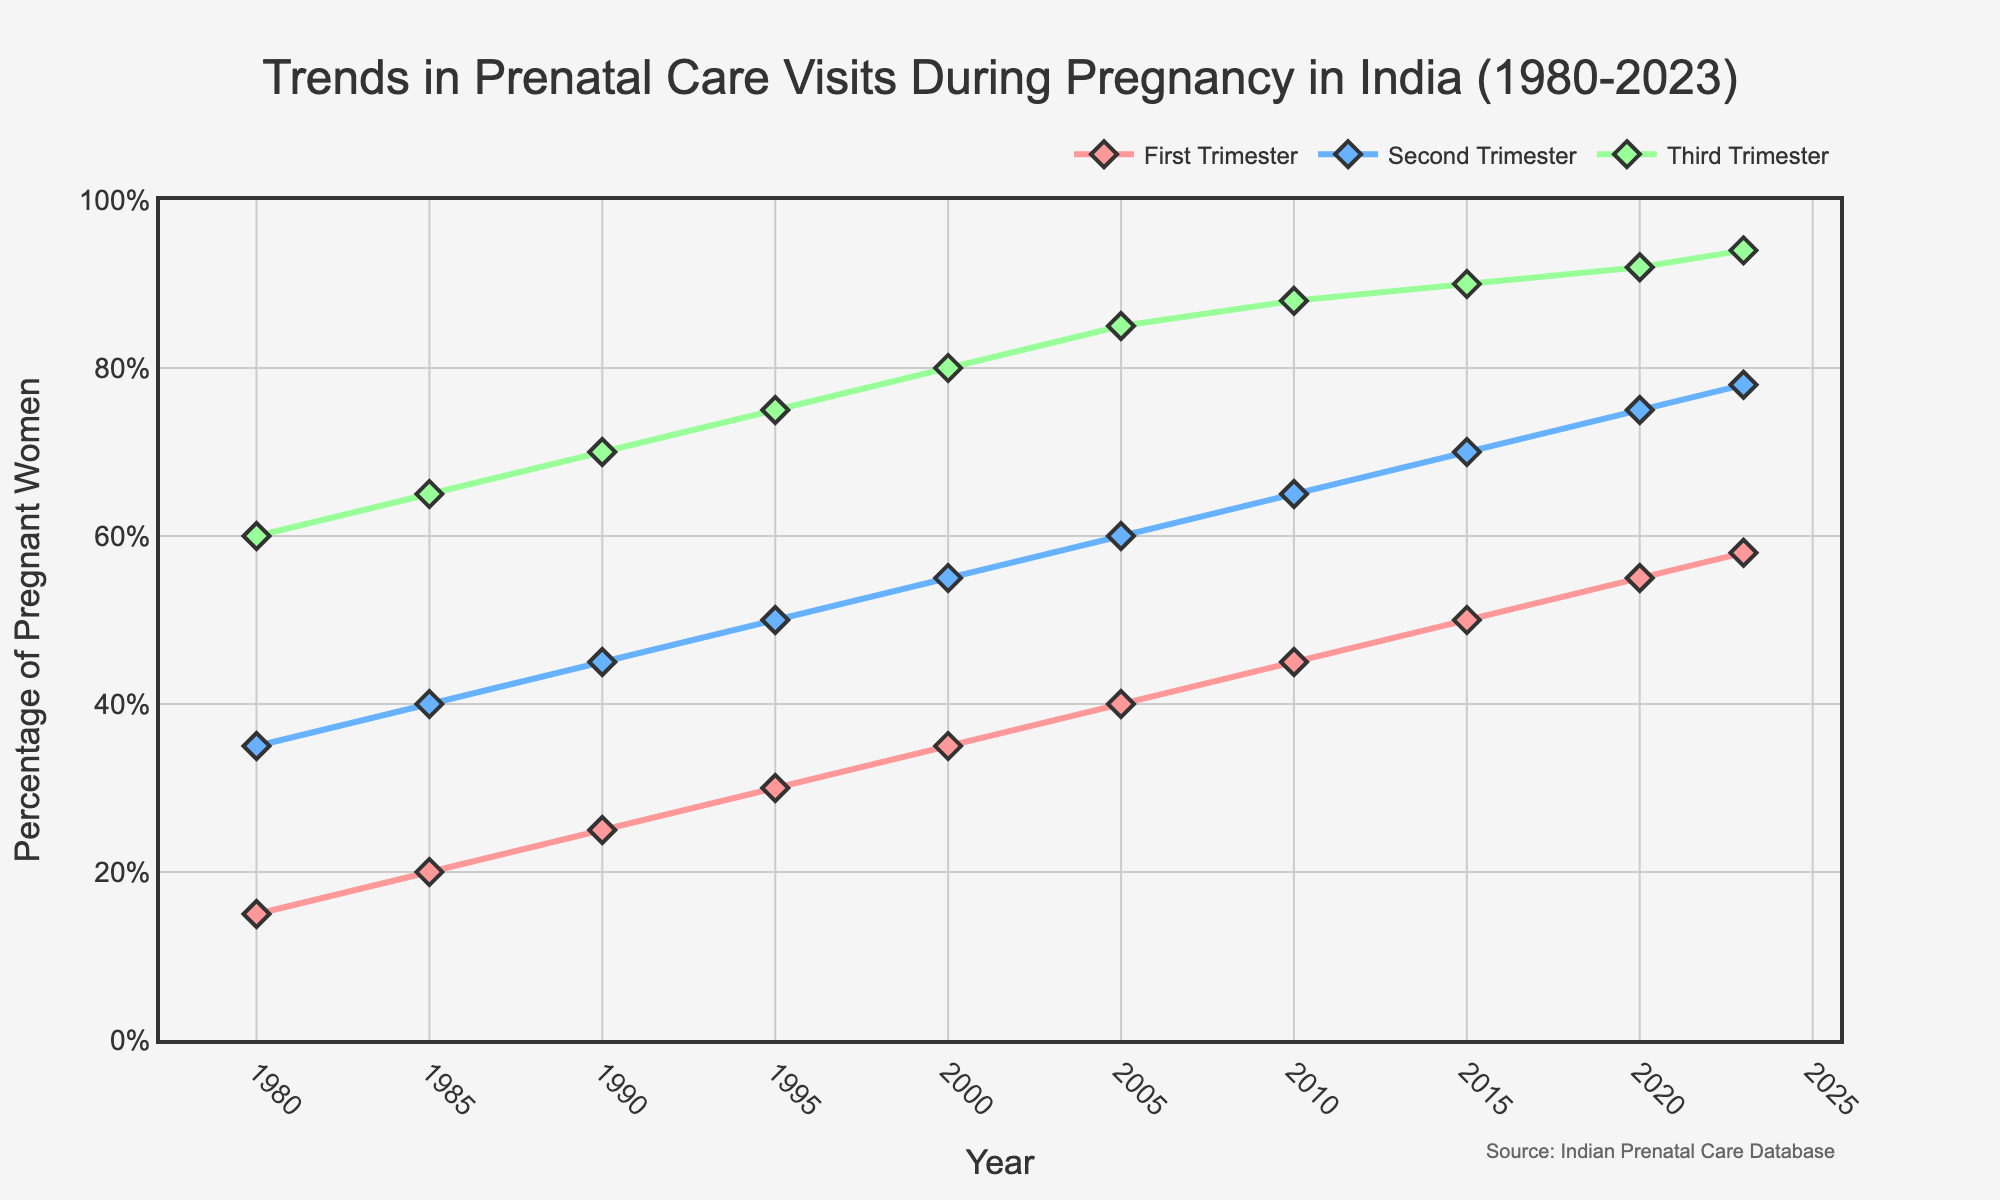What trend do you observe in prenatal care visits during the first trimester from 1980 to 2023? The percentage of pregnant women having prenatal care visits during the first trimester increased steadily from 15% in 1980 to 58% in 2023. This suggests an overall improvement in early prenatal care over the years.
Answer: Steady increase Which trimester had the highest percentage of prenatal care visits in 2023? In 2023, the third trimester had the highest percentage of prenatal care visits at 94%. This can be seen by comparing the three lines in the graph at the year 2023.
Answer: Third trimester What is the difference in the percentage of prenatal care visits between the second trimester and the first trimester in the year 2005? In 2005, the percentage of prenatal care visits during the second trimester was 60%, while it was 40% during the first trimester. The difference is found by subtracting 40% from 60%.
Answer: 20% How did the percentage of prenatal care visits during the third trimester change from 1985 to 2010? In 1985, the percentage was 65%, and by 2010, it had increased to 88%. Subtracting the earlier value from the later value (88% - 65%) shows the change.
Answer: 23% Between which years did the prenatal care visits during the second trimester see the greatest increase? The second trimester saw the greatest increase from 2010 to 2015, where the percentage rose from 65% to 70%. This is observed as the steepest slope on the graph for the second trimester.
Answer: 2010 to 2015 What is the average percentage of prenatal care visits during the first trimester from 1980 to 2023? The average is calculated by summing the percentages of the first trimester from 1980 to 2023 and then dividing by the number of data points. (15+20+25+30+35+40+45+50+55+58)/10 = 37.3%
Answer: 37.3% Compare the trends in prenatal care visits during the first and third trimesters from 1980 to 2023. Both the first and third trimesters show an upward trend in prenatal care visits from 1980 to 2023. However, the third trimester consistently has a higher percentage, reflecting a greater emphasis on later prenatal care. The gap between them narrows slightly over the years.
Answer: Upward trend for both with the third consistently higher What is the combined percentage of prenatal care visits across all trimesters in 1990? To find this, add the percentages for each trimester in 1990: 25% (first trimester) + 45% (second trimester) + 70% (third trimester).
Answer: 140% Which trimester shows the smallest overall increase in prenatal care visits from 1980 to 2023? The first trimester shows the smallest overall increase, starting at 15% in 1980 and rising to 58% in 2023, which is an increase of 43%. This can be compared to the increases in the other trimesters.
Answer: First trimester During which decade did the percentage of prenatal care visits during the second trimester reach 50%? The percentage of prenatal care visits during the second trimester reached 50% in the decade of the 1990s (specifically in 1995). This can be confirmed by looking at the year labels and values along the second trimester line.
Answer: 1990s 